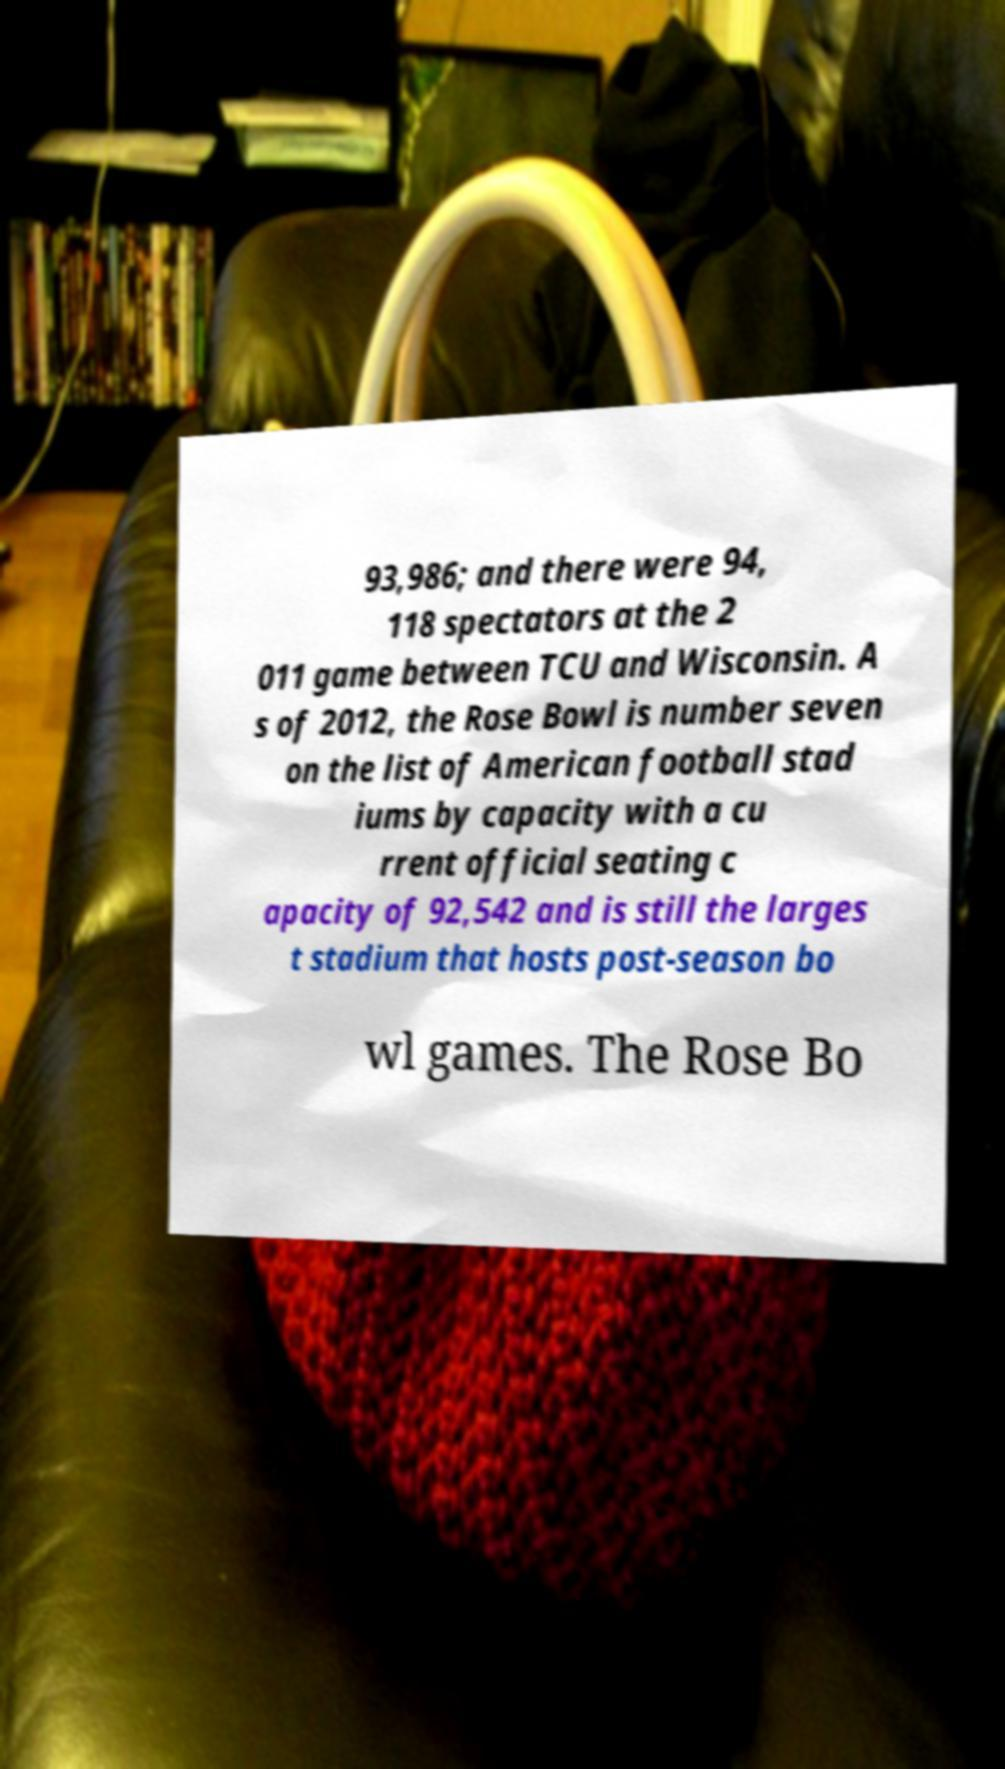Can you read and provide the text displayed in the image?This photo seems to have some interesting text. Can you extract and type it out for me? 93,986; and there were 94, 118 spectators at the 2 011 game between TCU and Wisconsin. A s of 2012, the Rose Bowl is number seven on the list of American football stad iums by capacity with a cu rrent official seating c apacity of 92,542 and is still the larges t stadium that hosts post-season bo wl games. The Rose Bo 